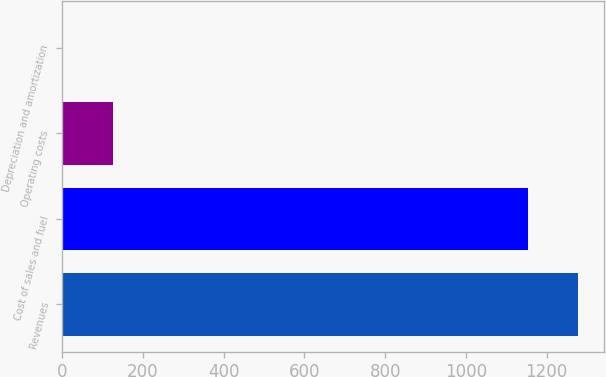Convert chart to OTSL. <chart><loc_0><loc_0><loc_500><loc_500><bar_chart><fcel>Revenues<fcel>Cost of sales and fuel<fcel>Operating costs<fcel>Depreciation and amortization<nl><fcel>1277.65<fcel>1152.6<fcel>125.15<fcel>0.1<nl></chart> 